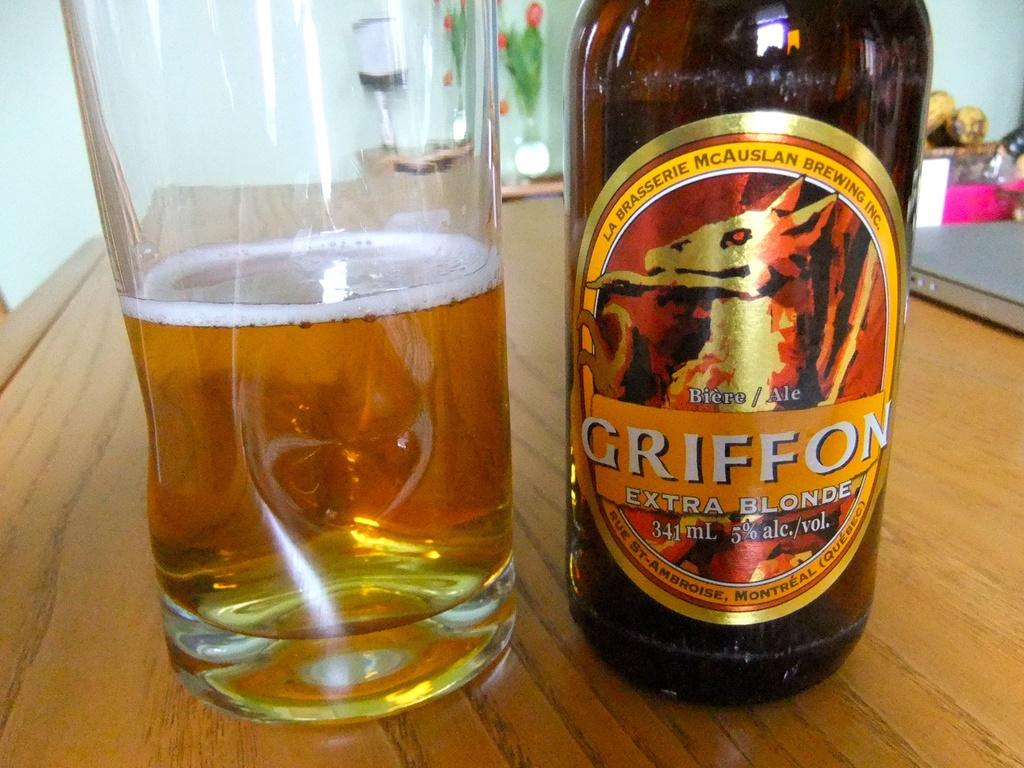<image>
Give a short and clear explanation of the subsequent image. A glass next to a bottle of griffon ale 